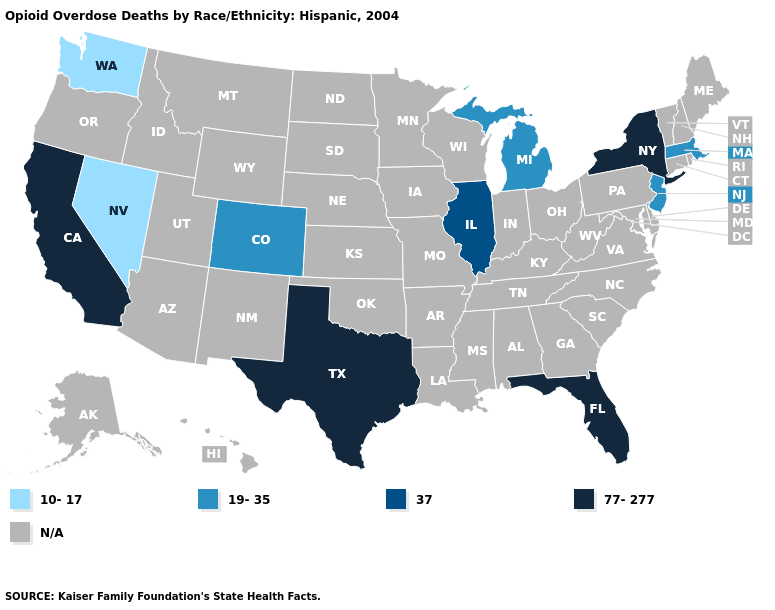What is the highest value in states that border Nevada?
Quick response, please. 77-277. Name the states that have a value in the range 77-277?
Be succinct. California, Florida, New York, Texas. Which states hav the highest value in the Northeast?
Keep it brief. New York. What is the value of Nevada?
Short answer required. 10-17. What is the lowest value in the USA?
Concise answer only. 10-17. Is the legend a continuous bar?
Write a very short answer. No. What is the highest value in the USA?
Give a very brief answer. 77-277. Does California have the highest value in the USA?
Quick response, please. Yes. Name the states that have a value in the range 37?
Quick response, please. Illinois. Name the states that have a value in the range 37?
Quick response, please. Illinois. What is the highest value in the USA?
Short answer required. 77-277. What is the highest value in the USA?
Answer briefly. 77-277. Does New Jersey have the highest value in the Northeast?
Short answer required. No. Among the states that border Louisiana , which have the highest value?
Keep it brief. Texas. 